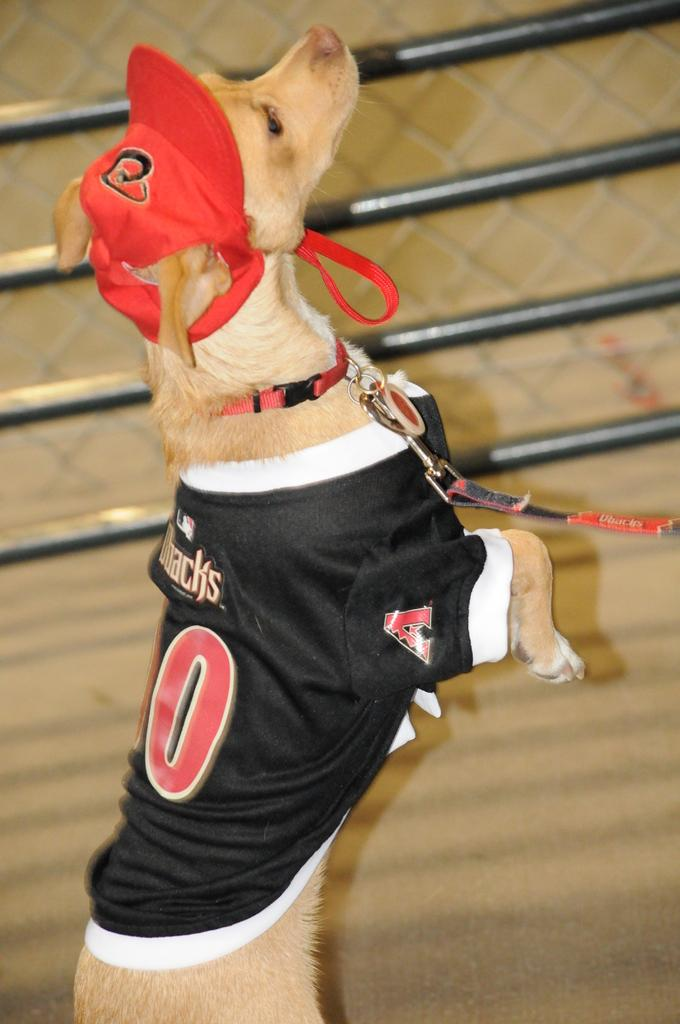Provide a one-sentence caption for the provided image. A dog on a leash wears a Dbacks baseball jersey. 